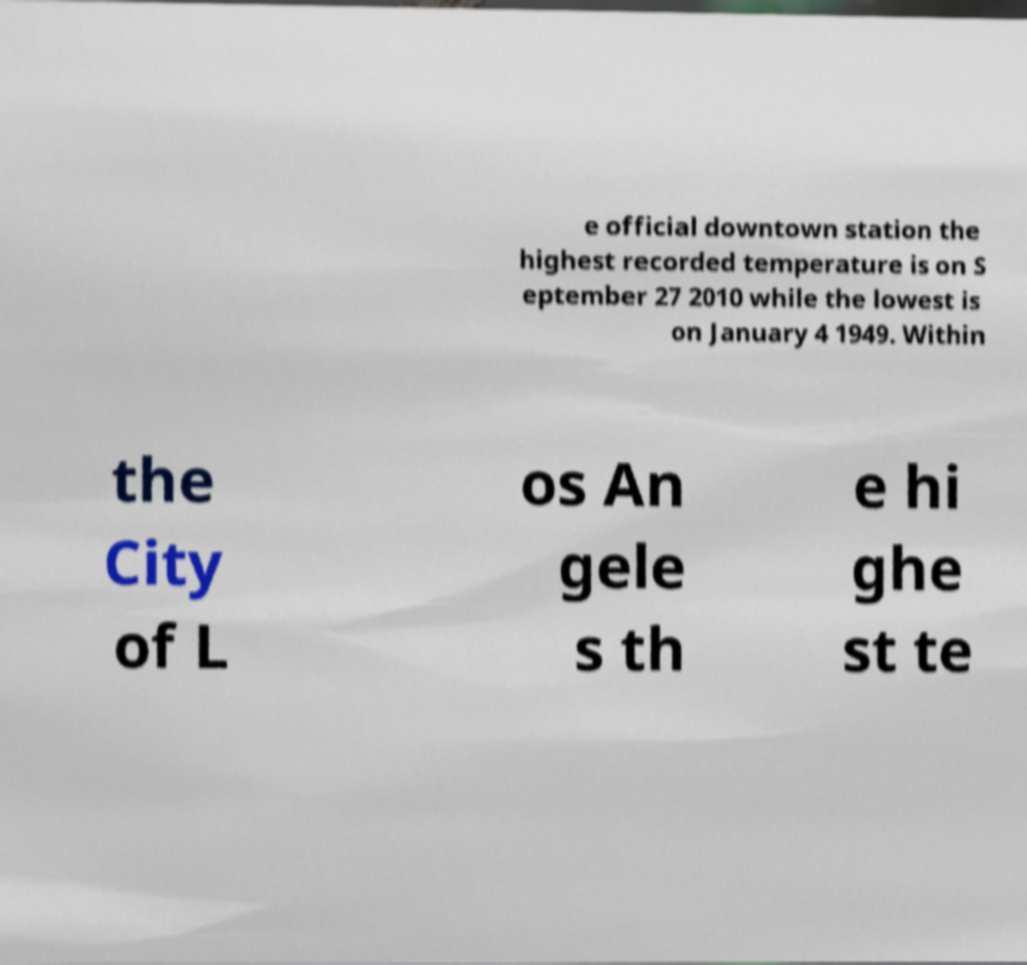Could you extract and type out the text from this image? e official downtown station the highest recorded temperature is on S eptember 27 2010 while the lowest is on January 4 1949. Within the City of L os An gele s th e hi ghe st te 